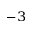<formula> <loc_0><loc_0><loc_500><loc_500>^ { - 3 }</formula> 